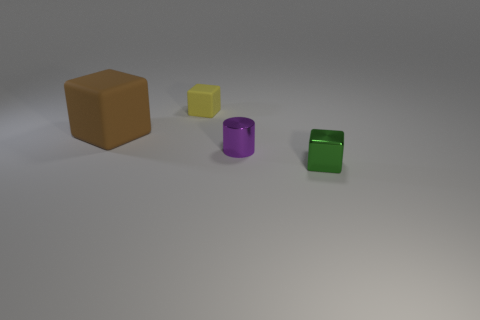What is the arrangement of the objects in the image? The objects are arranged from left to right in decreasing order of size, starting with a large brown cube followed by a smaller yellow cube, a purple cylinder, and finally a small green cube. 